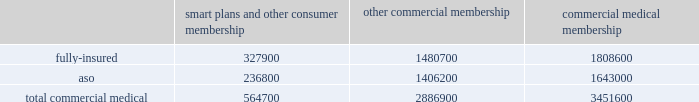We participate in a medicare health support pilot program through green ribbon health , or grh , a joint- venture company with pfizer health solutions inc .
Grh is designed to support medicare beneficiaries living with diabetes and/or congestive heart failure in central florida .
Grh uses disease management initiatives including evidence-based clinical guidelines , personal self-directed change strategies , and personal nurses to help participants navigate the health system .
Revenues under the contract with cms , which expires october 31 , 2008 unless terminated earlier , are subject to refund unless a savings target is met .
To date , all revenues have been deferred until reliable estimates are determinable .
Our products marketed to commercial segment employers and members smart plans and other consumer products over the last several years , we have developed and offered various commercial products designed to provide options and choices to employers that are annually facing substantial premium increases driven by double-digit medical cost inflation .
These smart plans , discussed more fully below , and other consumer offerings , which can be offered on either a fully-insured or aso basis , provided coverage to approximately 564700 members at december 31 , 2007 , representing approximately 16.4% ( 16.4 % ) of our total commercial medical membership as detailed below .
Smart plans and other consumer membership other commercial membership commercial medical membership .
These products are often offered to employer groups as 201cbundles 201d , where the subscribers are offered various hmo and ppo options , with various employer contribution strategies as determined by the employer .
Paramount to our product strategy , we have developed a group of innovative consumer products , styled as 201csmart 201d products , that we believe will be a long-term solution for employers .
We believe this new generation of products provides more ( 1 ) choices for the individual consumer , ( 2 ) transparency of provider costs , and ( 3 ) benefit designs that engage consumers in the costs and effectiveness of health care choices .
Innovative tools and technology are available to assist consumers with these decisions , including the trade-offs between higher premiums and point-of-service costs at the time consumers choose their plans , and to suggest ways in which the consumers can maximize their individual benefits at the point they use their plans .
We believe that when consumers can make informed choices about the cost and effectiveness of their health care , a sustainable long term solution for employers can be realized .
Smart products , which accounted for approximately 55% ( 55 % ) of enrollment in all of our consumer-choice plans as of december 31 , 2007 , are only sold to employers who use humana as their sole health insurance carrier .
Some employers have selected other types of consumer-choice products , such as , ( 1 ) a product with a high deductible , ( 2 ) a catastrophic coverage plan , or ( 3 ) ones that offer a spending account option in conjunction with more traditional medical coverage or as a stand alone plan .
Unlike our smart products , these products , while valuable in helping employers deal with near-term cost increases by shifting costs to employees , are not considered by us to be long-term comprehensive solutions to the employers 2019 cost dilemma , although we view them as an important interim step .
Our commercial hmo products provide prepaid health insurance coverage to our members through a network of independent primary care physicians , specialty physicians , and other health care providers who .
Considering the smart plans and other consumer membership , what is the percentage of the fully insured among the total commercial medical plans? 
Rationale: it is the number of members of the fully insured plans divided by the total number of members of the commercial medical plans .
Computations: (327900 / 564700)
Answer: 0.58066. 